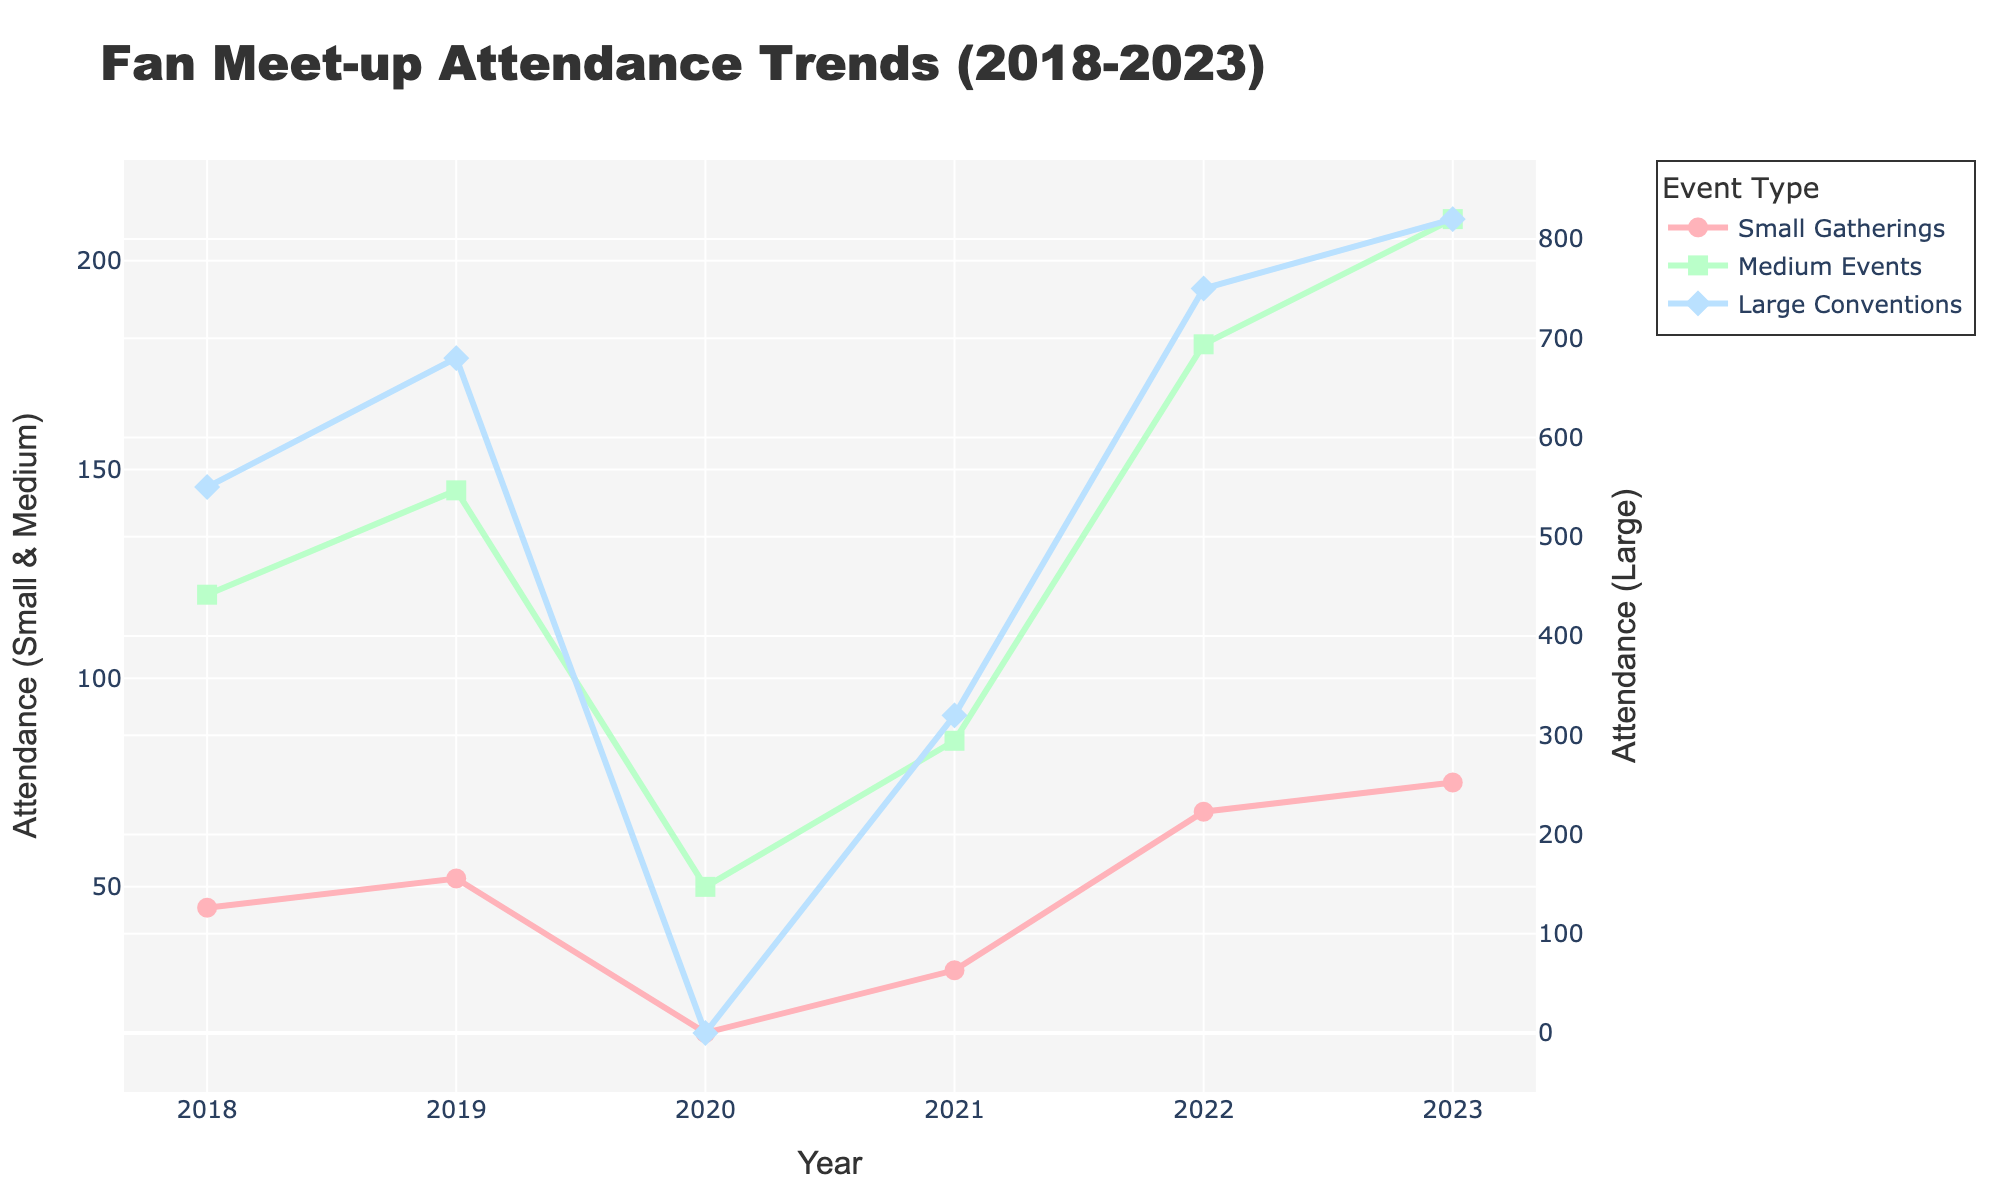Which year had the lowest attendance for small gatherings? The chart shows the attendance for small gatherings each year from 2018 to 2023. The smallest value occurs in 2020 with an attendance of 15.
Answer: 2020 What is the difference in attendance at large conventions between 2022 and 2020? The attendance at large conventions in 2022 was 750 and in 2020 it was 0. The difference is 750 - 0 = 750.
Answer: 750 What was the average attendance of medium events over the 5 years excluding 2020? The attendance for medium events in 2018, 2019, 2021, 2022, and 2023 are 120, 145, 85, 180, and 210 respectively. Summing these gives 120 + 145 + 85 + 180 + 210 = 740. The average is 740 / 5 = 148.
Answer: 148 In which year did medium events see the greatest increase in attendance compared to the previous year? To determine the greatest increase: 2019-2018: 145-120 = 25; 2021-2020: 85-50 = 35; 2022-2021: 180-85 = 95; 2023-2022: 210-180 = 30. The greatest increase is from 2021 to 2022 with an increase of 95.
Answer: 2022 Compare the attendance for small gatherings and medium events in 2023. Which was higher and by how much? The attendance for small gatherings in 2023 was 75, and for medium events, it was 210. The difference is 210 - 75 = 135. Medium events had higher attendance by 135.
Answer: Medium events by 135 Which event type had the most significant drop in attendance from its peak year? Large conventions had the most significant drop from 2019's 680 to 2020's 0, a drop of 680.
Answer: Large Conventions What was the total attendance for all event types combined in 2023? In 2023, the attendance for small gatherings was 75, medium events was 210, and large conventions was 820. Summing these gives 75 + 210 + 820 = 1105.
Answer: 1105 Was there any year where the attendance for large conventions was zero? The chart indicates that in 2020, the attendance for large conventions was 0.
Answer: 2020 